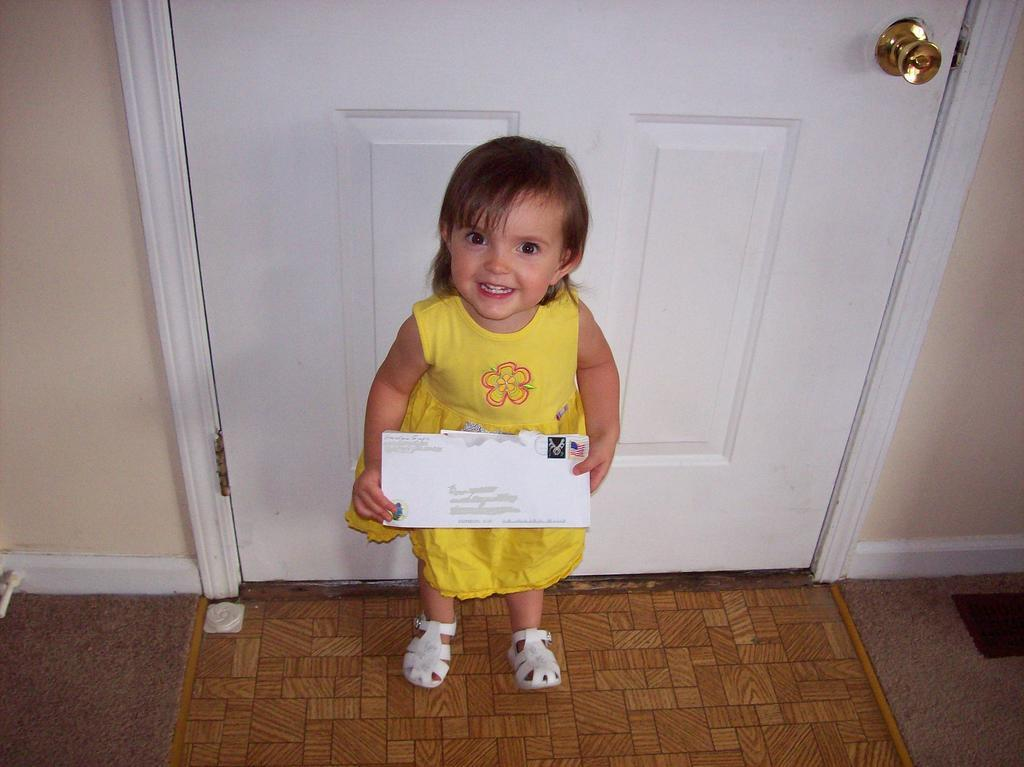Who is the main subject in the image? There is a girl in the image. What is the girl doing in the image? The girl is standing in the image. What is the girl holding in her hand? The girl is holding an envelope in her hand. What can be seen behind the girl in the image? There is a door visible behind the girl. Is the girl riding a bike in the image? No, the girl is not riding a bike in the image; she is standing and holding an envelope. 